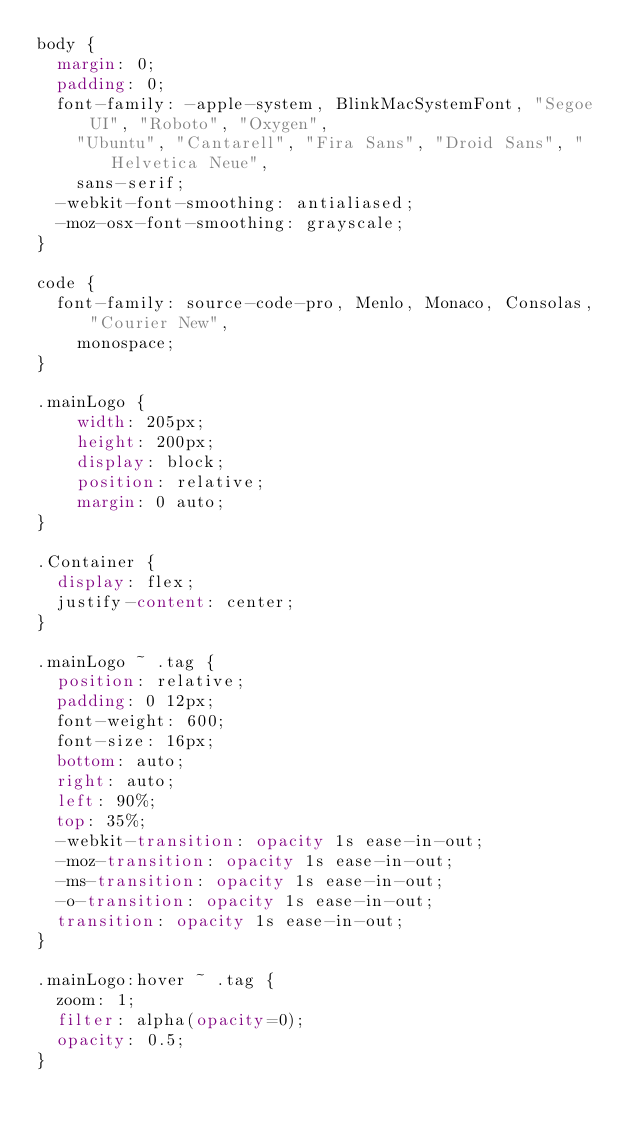Convert code to text. <code><loc_0><loc_0><loc_500><loc_500><_CSS_>body {
  margin: 0;
  padding: 0;
  font-family: -apple-system, BlinkMacSystemFont, "Segoe UI", "Roboto", "Oxygen",
    "Ubuntu", "Cantarell", "Fira Sans", "Droid Sans", "Helvetica Neue",
    sans-serif;
  -webkit-font-smoothing: antialiased;
  -moz-osx-font-smoothing: grayscale;
}

code {
  font-family: source-code-pro, Menlo, Monaco, Consolas, "Courier New",
    monospace;
}

.mainLogo {
    width: 205px;
    height: 200px;
    display: block;
    position: relative;
    margin: 0 auto;
}

.Container {
  display: flex;
  justify-content: center;
}

.mainLogo ~ .tag {
  position: relative;
  padding: 0 12px;
  font-weight: 600;
  font-size: 16px;
  bottom: auto;
  right: auto;
  left: 90%;
  top: 35%;
  -webkit-transition: opacity 1s ease-in-out;
  -moz-transition: opacity 1s ease-in-out;
  -ms-transition: opacity 1s ease-in-out;
  -o-transition: opacity 1s ease-in-out;
  transition: opacity 1s ease-in-out;
}

.mainLogo:hover ~ .tag {
  zoom: 1;
  filter: alpha(opacity=0);
  opacity: 0.5;
}
</code> 